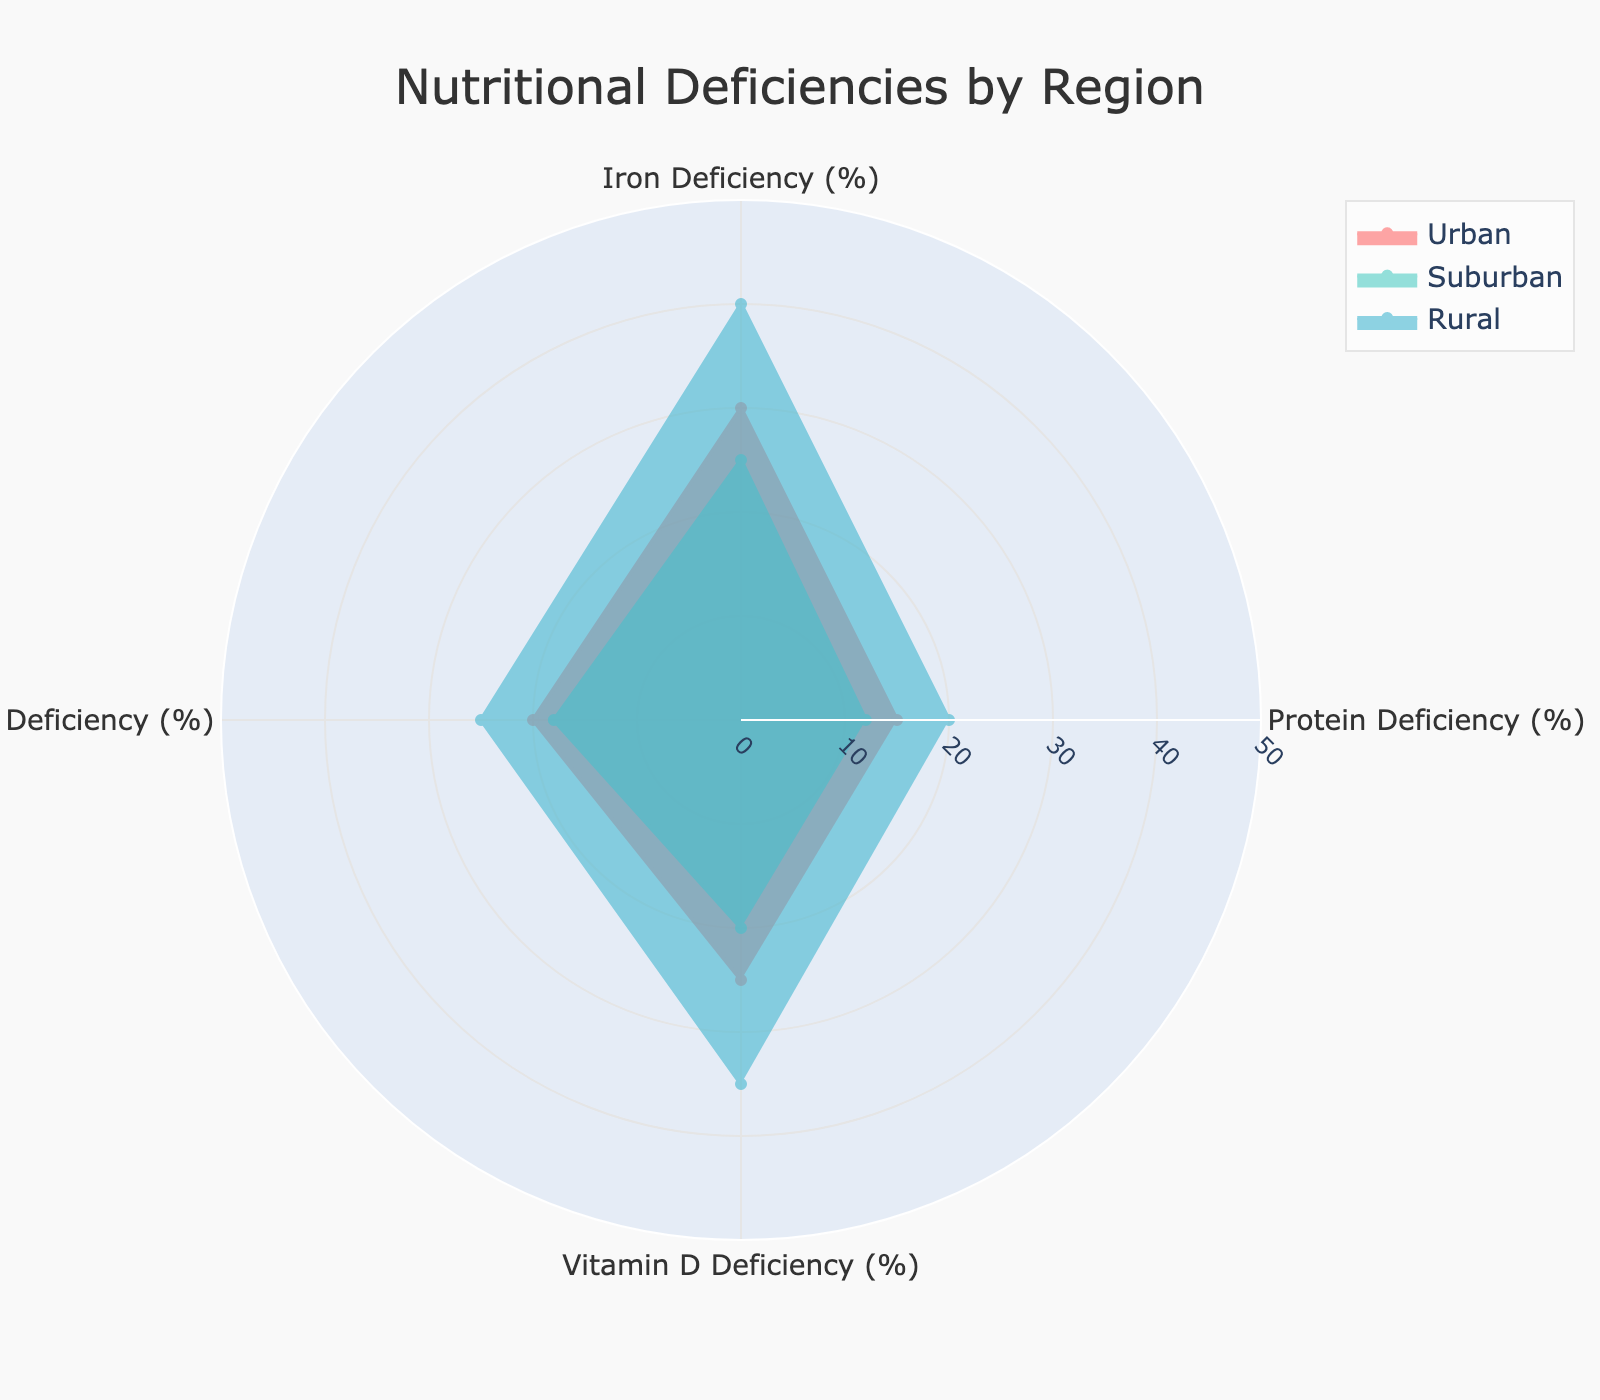What is the title of the figure? The title is typically displayed at the top of the figure. In this case, it reads "Nutritional Deficiencies by Region".
Answer: Nutritional Deficiencies by Region Which region has the highest Vitamin D Deficiency? By observing the extend of the shaded areas for each region in the Vitamin D Deficiency category, the largest one is for the Rural region, reaching 35%.
Answer: Rural What is the average Protein Deficiency across all regions? To find the average Protein Deficiency, add the percentages of all three regions and divide by three: (15 + 12 + 20) / 3 = 47 / 3 = 15.67%.
Answer: 15.67% How much greater is the Iron Deficiency in Rural areas compared to Urban areas? Subtract the Iron Deficiency percentage in Urban areas from that in Rural areas: 40% - 30% = 10%.
Answer: 10% Which deficiency shows the largest difference between Urban and Rural regions? Compare the differences in each deficiency category between Urban and Rural regions: Protein Deficiency (5%), Iron Deficiency (10%), Vitamin A Deficiency (5%), Vitamin D Deficiency (10%). The differences for Iron and Vitamin D Deficiency are both 10%, and they are the largest.
Answer: Iron Deficiency and Vitamin D Deficiency What is the color used to represent the Suburban region? Look at the color key in the legend corresponding to the Suburban region, which is a shade of teal.
Answer: Teal Compare the Vitamin A Deficiency in Urban and Suburban regions and state which one is higher. The radar chart shows the extent of the shaded areas in the Vitamin A Deficiency category. Urban has 20% whereas Suburban has 18%, so Urban is higher.
Answer: Urban Is there any deficiency where the Rural region shows the least prevalence compared to Urban and Suburban regions? By analyzing each category, Rural always shows higher or equal prevalence in all deficiencies compared to Urban and Suburban regions. There's no deficiency where Rural is the least.
Answer: No What is the sum of Vitamin A and Vitamin D Deficiencies in Suburban regions? Combine the values for Vitamin A (18%) and Vitamin D (20%) deficiencies in Suburban regions: 18 + 20 = 38%.
Answer: 38% List all nutritional deficiencies for the Urban region. The categories are listed around the radar chart, and their respective values for Urban region are: Protein Deficiency (15%), Iron Deficiency (30%), Vitamin A Deficiency (20%), Vitamin D Deficiency (25%).
Answer: Protein (15%), Iron (30%), Vitamin A (20%), Vitamin D (25%) 